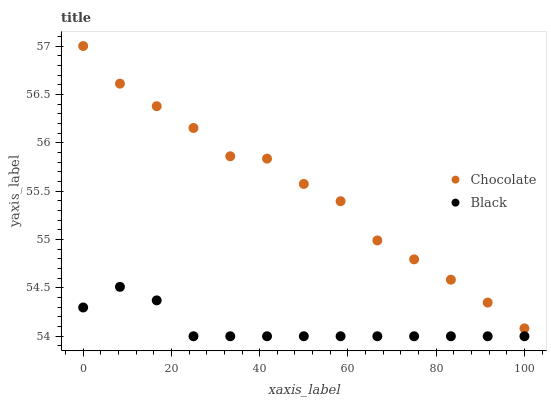Does Black have the minimum area under the curve?
Answer yes or no. Yes. Does Chocolate have the maximum area under the curve?
Answer yes or no. Yes. Does Chocolate have the minimum area under the curve?
Answer yes or no. No. Is Black the smoothest?
Answer yes or no. Yes. Is Chocolate the roughest?
Answer yes or no. Yes. Is Chocolate the smoothest?
Answer yes or no. No. Does Black have the lowest value?
Answer yes or no. Yes. Does Chocolate have the lowest value?
Answer yes or no. No. Does Chocolate have the highest value?
Answer yes or no. Yes. Is Black less than Chocolate?
Answer yes or no. Yes. Is Chocolate greater than Black?
Answer yes or no. Yes. Does Black intersect Chocolate?
Answer yes or no. No. 